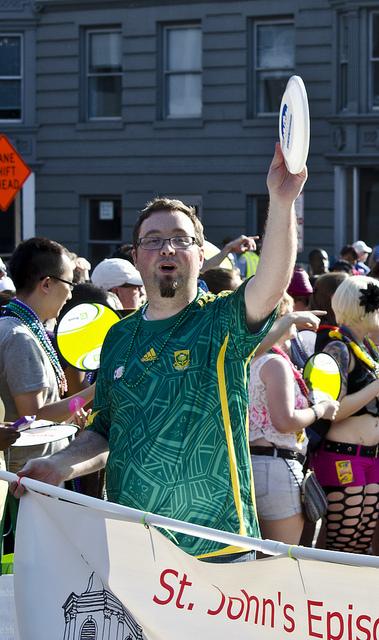Did he just win a game?
Short answer required. No. What is the man holding?
Quick response, please. Frisbee. What is behind the man?
Answer briefly. Crowd. 